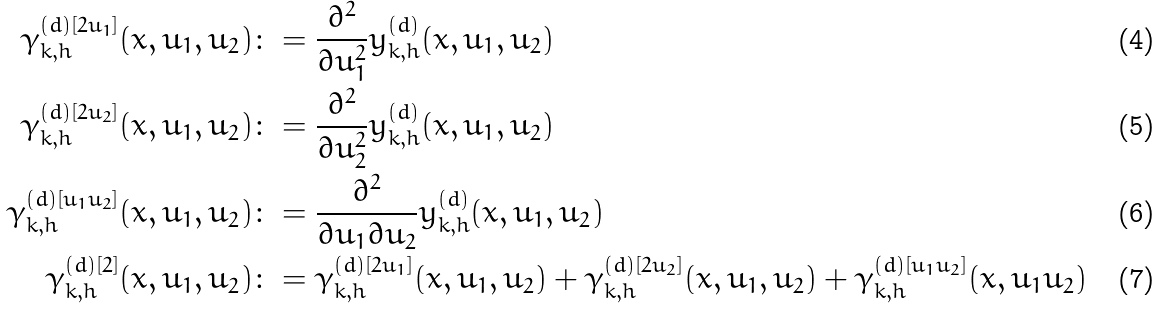Convert formula to latex. <formula><loc_0><loc_0><loc_500><loc_500>\gamma _ { k , h } ^ { ( d ) [ 2 u _ { 1 } ] } ( x , u _ { 1 } , u _ { 2 } ) & \colon = \frac { \partial ^ { 2 } } { \partial u _ { 1 } ^ { 2 } } y _ { k , h } ^ { ( d ) } ( x , u _ { 1 } , u _ { 2 } ) \\ \gamma _ { k , h } ^ { ( d ) [ 2 u _ { 2 } ] } ( x , u _ { 1 } , u _ { 2 } ) & \colon = \frac { \partial ^ { 2 } } { \partial u _ { 2 } ^ { 2 } } y _ { k , h } ^ { ( d ) } ( x , u _ { 1 } , u _ { 2 } ) \\ \gamma _ { k , h } ^ { ( d ) [ u _ { 1 } u _ { 2 } ] } ( x , u _ { 1 } , u _ { 2 } ) & \colon = \frac { \partial ^ { 2 } } { \partial u _ { 1 } \partial u _ { 2 } } y _ { k , h } ^ { ( d ) } ( x , u _ { 1 } , u _ { 2 } ) \\ \gamma _ { k , h } ^ { ( d ) [ 2 ] } ( x , u _ { 1 } , u _ { 2 } ) & \colon = \gamma _ { k , h } ^ { ( d ) [ 2 u _ { 1 } ] } ( x , u _ { 1 } , u _ { 2 } ) + \gamma _ { k , h } ^ { ( d ) [ 2 u _ { 2 } ] } ( x , u _ { 1 } , u _ { 2 } ) + \gamma _ { k , h } ^ { ( d ) [ u _ { 1 } u _ { 2 } ] } ( x , u _ { 1 } u _ { 2 } )</formula> 